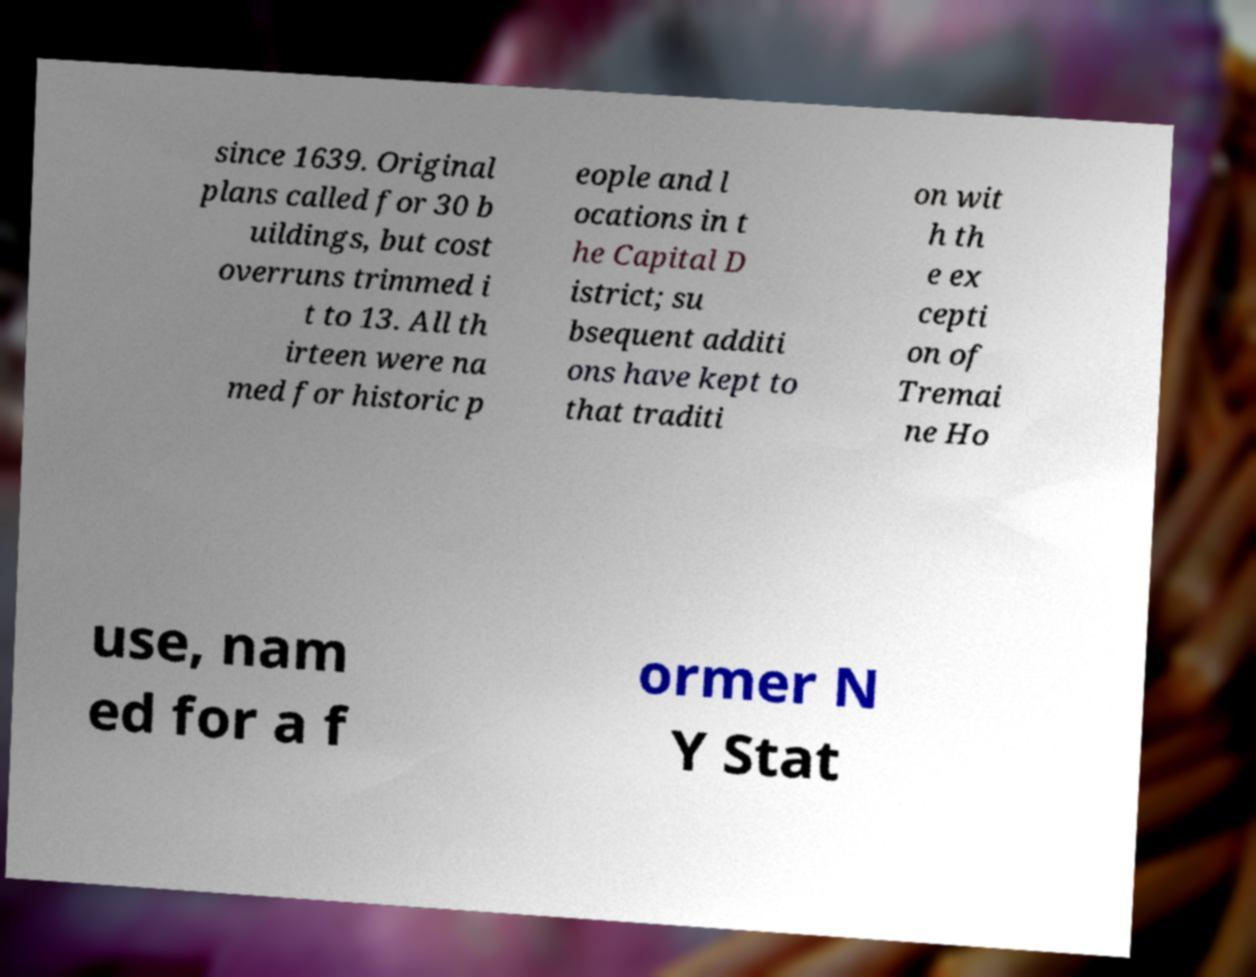Could you extract and type out the text from this image? since 1639. Original plans called for 30 b uildings, but cost overruns trimmed i t to 13. All th irteen were na med for historic p eople and l ocations in t he Capital D istrict; su bsequent additi ons have kept to that traditi on wit h th e ex cepti on of Tremai ne Ho use, nam ed for a f ormer N Y Stat 